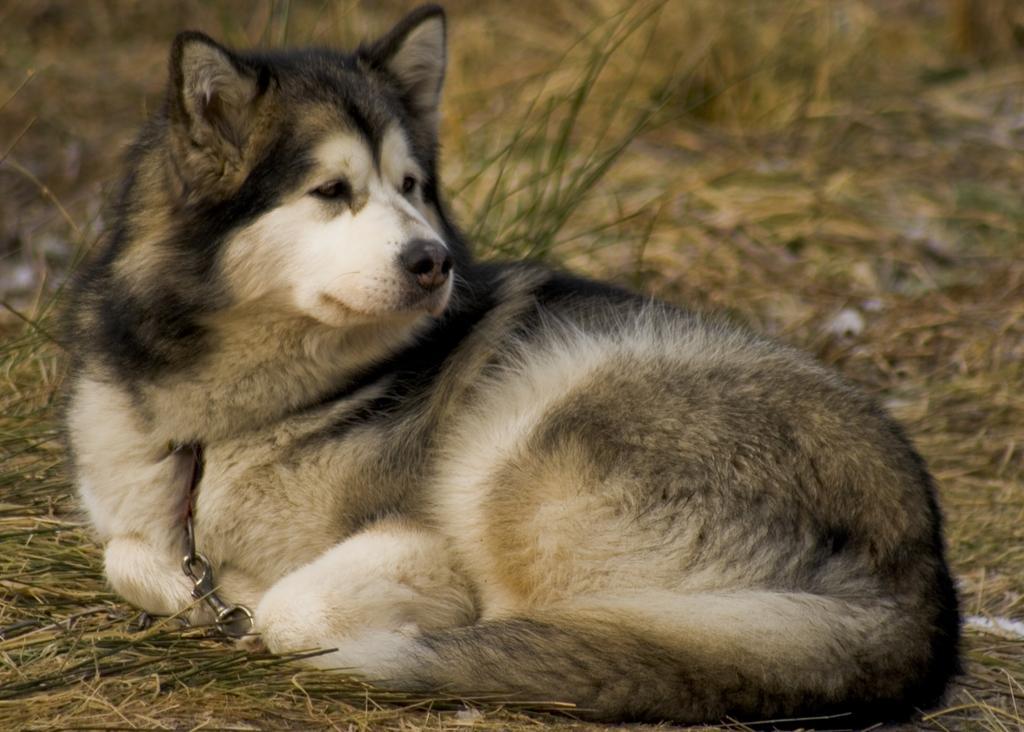How would you summarize this image in a sentence or two? In the image there is an animal on the grass surface and the background of the animal is blur. 